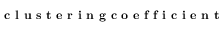<formula> <loc_0><loc_0><loc_500><loc_500>c l u s t e r i n g c o e f f i c i e n t</formula> 